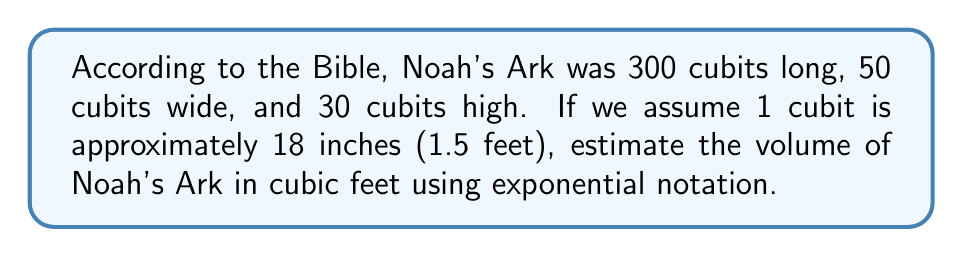Can you answer this question? Let's approach this step-by-step:

1. Convert the dimensions from cubits to feet:
   Length: $300 \times 1.5 = 450$ feet
   Width: $50 \times 1.5 = 75$ feet
   Height: $30 \times 1.5 = 45$ feet

2. Calculate the volume using the formula for a rectangular prism:
   $V = length \times width \times height$
   $V = 450 \times 75 \times 45$

3. Multiply these numbers:
   $450 \times 75 = 33,750$
   $33,750 \times 45 = 1,518,750$

4. Express this in exponential notation:
   $1,518,750 = 1.51875 \times 10^6$

5. Round to two decimal places:
   $1.52 \times 10^6$ cubic feet

This large number helps us understand the immense size of Noah's Ark as described in the Bible. It shows how God provided a vessel capable of housing many animals and supplies for the great flood.
Answer: $1.52 \times 10^6$ cubic feet 